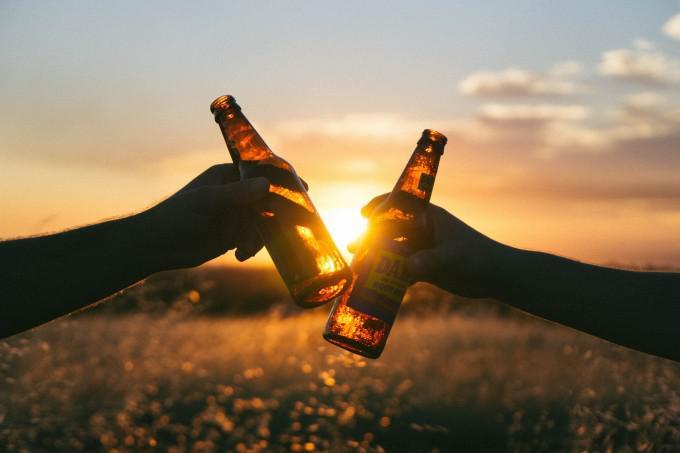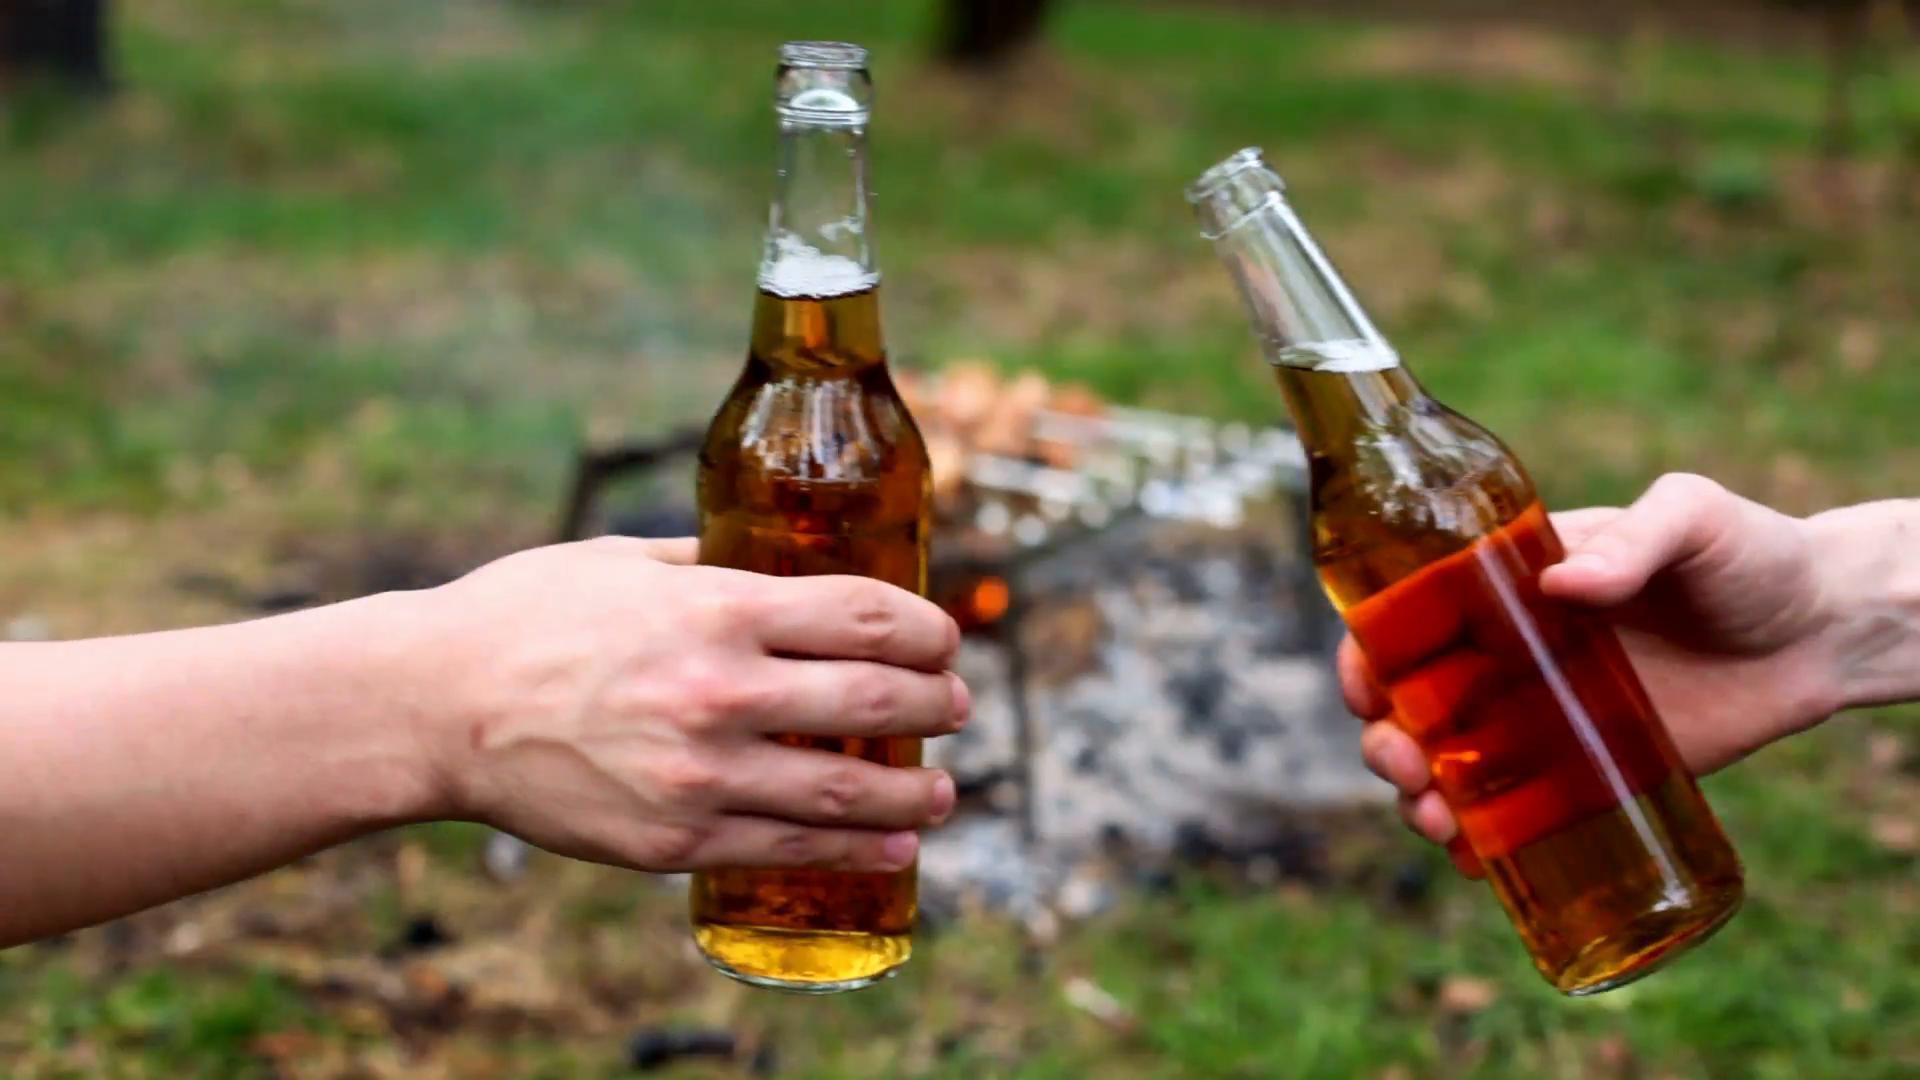The first image is the image on the left, the second image is the image on the right. Examine the images to the left and right. Is the description "People are clinking two brown bottles together in one of the images." accurate? Answer yes or no. Yes. The first image is the image on the left, the second image is the image on the right. Evaluate the accuracy of this statement regarding the images: "Both images are taken outdoors and in at least one of them, a campfire with food is in the background.". Is it true? Answer yes or no. Yes. 